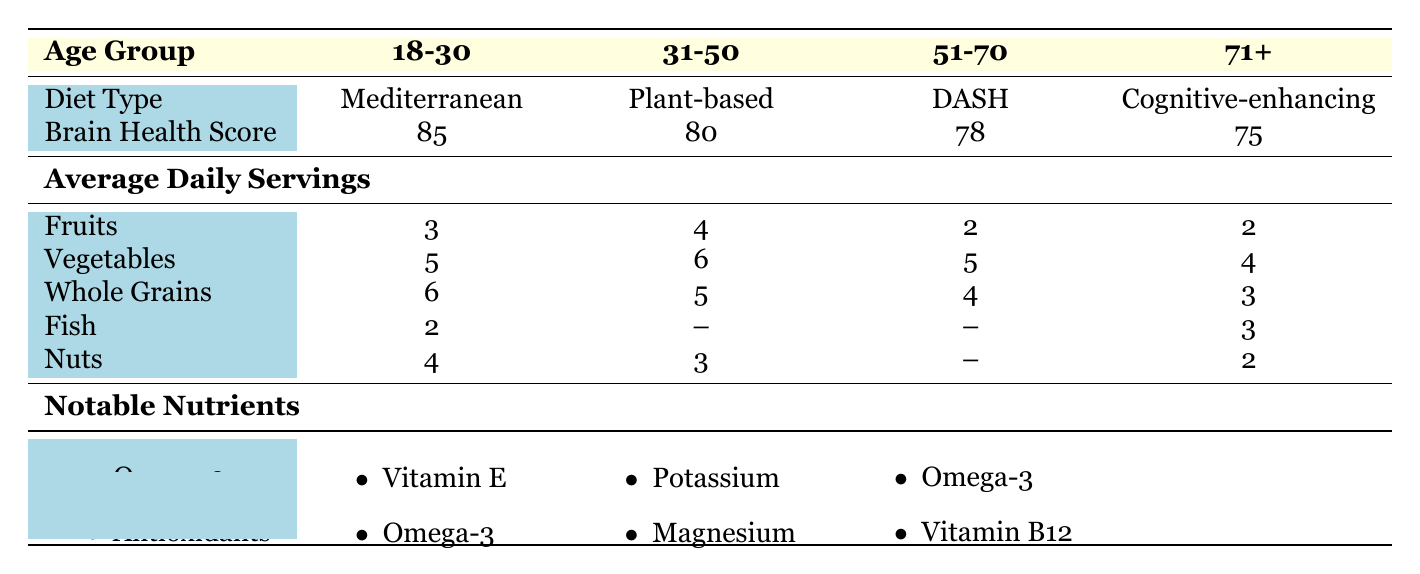What is the brain health score for the 31-50 age group? The table shows that the brain health score for the 31-50 age group is 80.
Answer: 80 Which diet type corresponds to individuals aged 51-70? According to the table, the diet type for individuals aged 51-70 is DASH.
Answer: DASH How many servings of vegetables do people aged 18-30 typically consume daily? The table indicates that people aged 18-30 consume an average of 5 servings of vegetables per day.
Answer: 5 Is the average daily serving of nuts higher in the 18-30 age group than in the 71 and above group? The average daily serving of nuts for the 18-30 age group is 4, while for the 71 and above group, it is 2. Since 4 is greater than 2, the statement is true.
Answer: Yes What is the combined total of average daily servings for fruits and vegetables for the 31-50 age group? For the 31-50 age group, the average daily servings are 4 for fruits and 6 for vegetables. Therefore, the combined total is 4 + 6 = 10.
Answer: 10 Which age group has the lowest brain health score and what is that score? The age group with the lowest brain health score is 71 and above, with a score of 75.
Answer: 71 and above: 75 How many more servings of whole grains does the 18-30 age group consume compared to the 51-70 age group? The 18-30 age group consumes 6 servings of whole grains while the 51-70 age group consumes 4 servings. The difference is 6 - 4 = 2.
Answer: 2 servings If we consider the notable nutrients, which nutrients are shared between the 18-30 and the 31-50 age groups? Both age groups have Omega-3 fatty acids listed as a notable nutrient, which means it is shared between them.
Answer: Omega-3 fatty acids What is the average number of servings for whole grains across all age groups? The average number of servings for whole grains is calculated as follows: (6 + 5 + 4 + 3) / 4 = 4.5.
Answer: 4.5 servings If someone aged 71 and above consumes 3 servings of fish, how does that compare to the servings of fish for the 18-30 age group? The 18-30 age group consumes 2 servings of fish. Since 3 servings (71 and above) is greater than 2 servings (18-30), the 71 and above group consumes more fish.
Answer: 71 and above group consumes more fish 